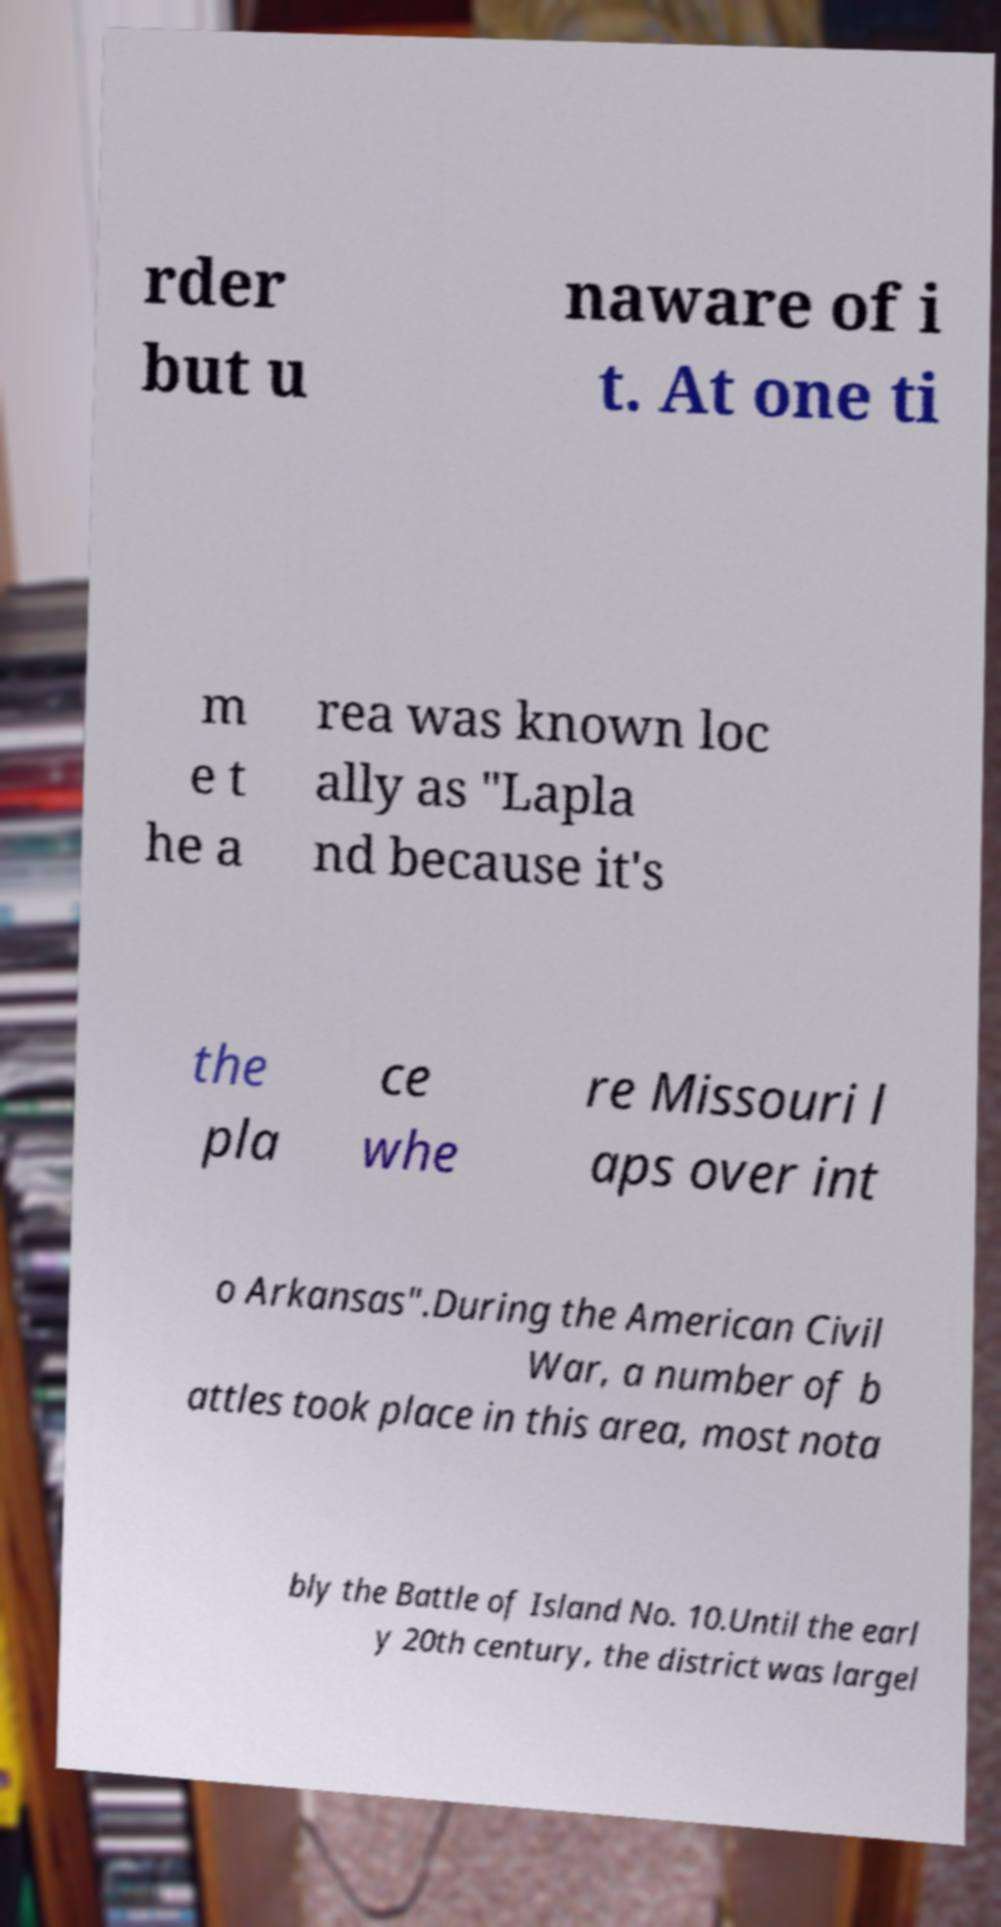Can you accurately transcribe the text from the provided image for me? rder but u naware of i t. At one ti m e t he a rea was known loc ally as "Lapla nd because it's the pla ce whe re Missouri l aps over int o Arkansas".During the American Civil War, a number of b attles took place in this area, most nota bly the Battle of Island No. 10.Until the earl y 20th century, the district was largel 